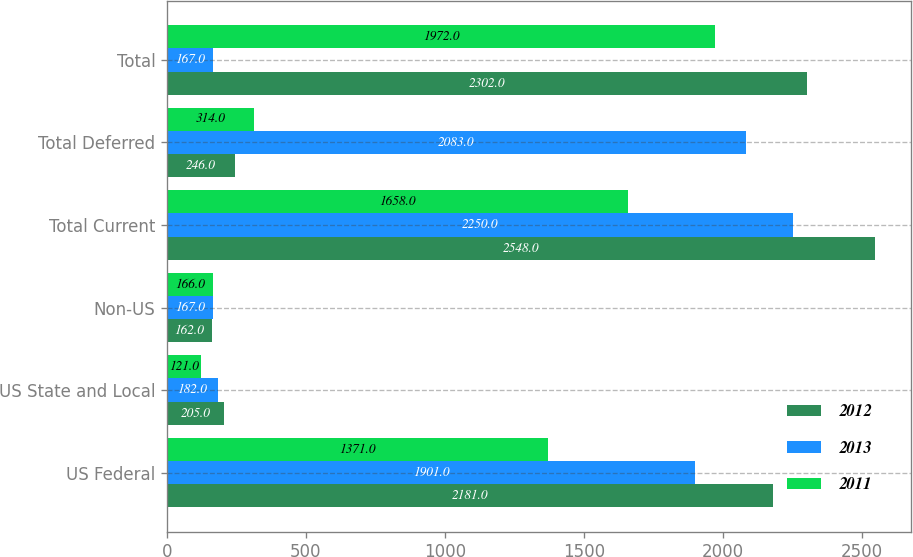<chart> <loc_0><loc_0><loc_500><loc_500><stacked_bar_chart><ecel><fcel>US Federal<fcel>US State and Local<fcel>Non-US<fcel>Total Current<fcel>Total Deferred<fcel>Total<nl><fcel>2012<fcel>2181<fcel>205<fcel>162<fcel>2548<fcel>246<fcel>2302<nl><fcel>2013<fcel>1901<fcel>182<fcel>167<fcel>2250<fcel>2083<fcel>167<nl><fcel>2011<fcel>1371<fcel>121<fcel>166<fcel>1658<fcel>314<fcel>1972<nl></chart> 